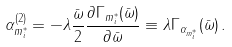Convert formula to latex. <formula><loc_0><loc_0><loc_500><loc_500>\alpha ^ { ( 2 ) } _ { m ^ { * } _ { i } } = - \lambda \frac { \bar { \omega } } { 2 } \frac { \partial \Gamma _ { m ^ { * } _ { i } } ( \bar { \omega } ) } { \partial \bar { \omega } } \equiv \lambda \Gamma _ { \alpha _ { m ^ { * } _ { i } } } ( \bar { \omega } ) \, .</formula> 